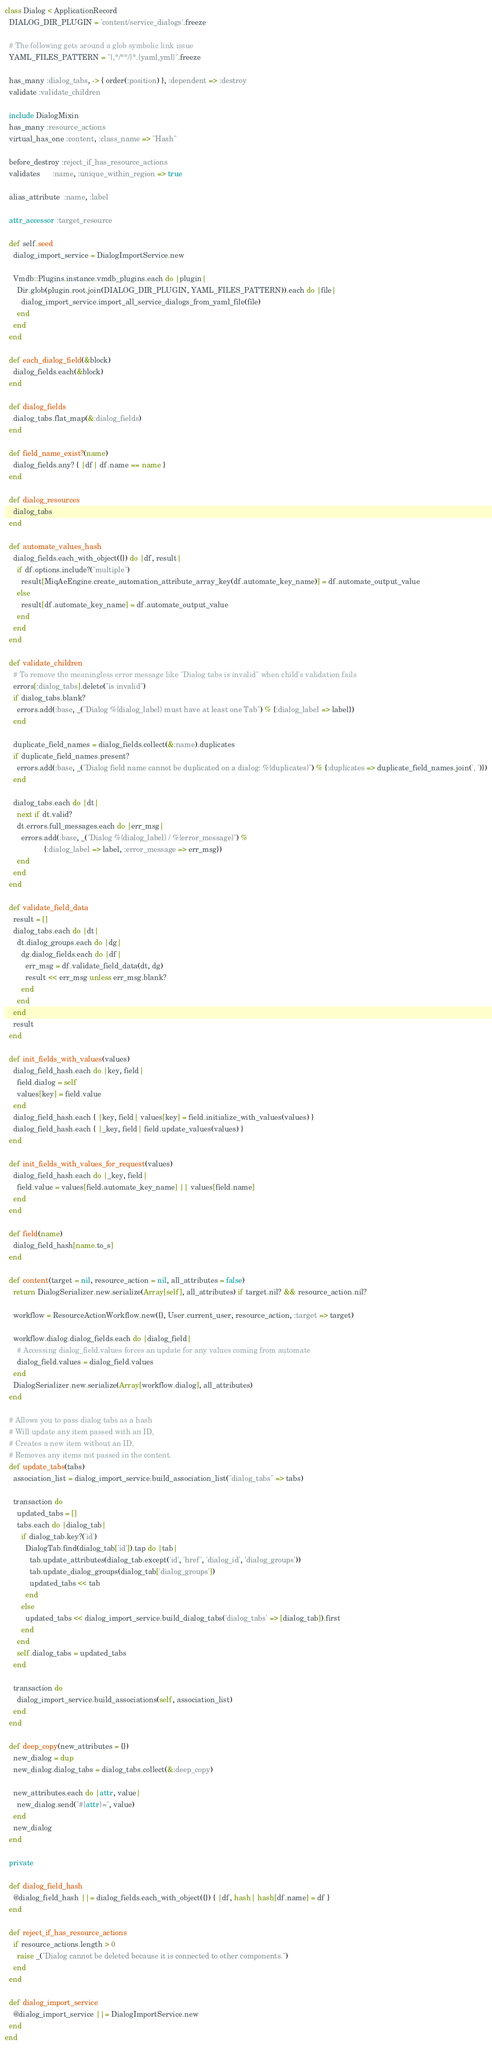<code> <loc_0><loc_0><loc_500><loc_500><_Ruby_>class Dialog < ApplicationRecord
  DIALOG_DIR_PLUGIN = 'content/service_dialogs'.freeze

  # The following gets around a glob symbolic link issue
  YAML_FILES_PATTERN = "{,*/**/}*.{yaml,yml}".freeze

  has_many :dialog_tabs, -> { order(:position) }, :dependent => :destroy
  validate :validate_children

  include DialogMixin
  has_many :resource_actions
  virtual_has_one :content, :class_name => "Hash"

  before_destroy :reject_if_has_resource_actions
  validates      :name, :unique_within_region => true

  alias_attribute  :name, :label

  attr_accessor :target_resource

  def self.seed
    dialog_import_service = DialogImportService.new

    Vmdb::Plugins.instance.vmdb_plugins.each do |plugin|
      Dir.glob(plugin.root.join(DIALOG_DIR_PLUGIN, YAML_FILES_PATTERN)).each do |file|
        dialog_import_service.import_all_service_dialogs_from_yaml_file(file)
      end
    end
  end

  def each_dialog_field(&block)
    dialog_fields.each(&block)
  end

  def dialog_fields
    dialog_tabs.flat_map(&:dialog_fields)
  end

  def field_name_exist?(name)
    dialog_fields.any? { |df| df.name == name }
  end

  def dialog_resources
    dialog_tabs
  end

  def automate_values_hash
    dialog_fields.each_with_object({}) do |df, result|
      if df.options.include?("multiple")
        result[MiqAeEngine.create_automation_attribute_array_key(df.automate_key_name)] = df.automate_output_value
      else
        result[df.automate_key_name] = df.automate_output_value
      end
    end
  end

  def validate_children
    # To remove the meaningless error message like "Dialog tabs is invalid" when child's validation fails
    errors[:dialog_tabs].delete("is invalid")
    if dialog_tabs.blank?
      errors.add(:base, _("Dialog %{dialog_label} must have at least one Tab") % {:dialog_label => label})
    end

    duplicate_field_names = dialog_fields.collect(&:name).duplicates
    if duplicate_field_names.present?
      errors.add(:base, _("Dialog field name cannot be duplicated on a dialog: %{duplicates}") % {:duplicates => duplicate_field_names.join(', ')})
    end

    dialog_tabs.each do |dt|
      next if dt.valid?
      dt.errors.full_messages.each do |err_msg|
        errors.add(:base, _("Dialog %{dialog_label} / %{error_message}") %
                   {:dialog_label => label, :error_message => err_msg})
      end
    end
  end

  def validate_field_data
    result = []
    dialog_tabs.each do |dt|
      dt.dialog_groups.each do |dg|
        dg.dialog_fields.each do |df|
          err_msg = df.validate_field_data(dt, dg)
          result << err_msg unless err_msg.blank?
        end
      end
    end
    result
  end

  def init_fields_with_values(values)
    dialog_field_hash.each do |key, field|
      field.dialog = self
      values[key] = field.value
    end
    dialog_field_hash.each { |key, field| values[key] = field.initialize_with_values(values) }
    dialog_field_hash.each { |_key, field| field.update_values(values) }
  end

  def init_fields_with_values_for_request(values)
    dialog_field_hash.each do |_key, field|
      field.value = values[field.automate_key_name] || values[field.name]
    end
  end

  def field(name)
    dialog_field_hash[name.to_s]
  end

  def content(target = nil, resource_action = nil, all_attributes = false)
    return DialogSerializer.new.serialize(Array[self], all_attributes) if target.nil? && resource_action.nil?

    workflow = ResourceActionWorkflow.new({}, User.current_user, resource_action, :target => target)

    workflow.dialog.dialog_fields.each do |dialog_field|
      # Accessing dialog_field.values forces an update for any values coming from automate
      dialog_field.values = dialog_field.values
    end
    DialogSerializer.new.serialize(Array[workflow.dialog], all_attributes)
  end

  # Allows you to pass dialog tabs as a hash
  # Will update any item passed with an ID,
  # Creates a new item without an ID,
  # Removes any items not passed in the content.
  def update_tabs(tabs)
    association_list = dialog_import_service.build_association_list("dialog_tabs" => tabs)

    transaction do
      updated_tabs = []
      tabs.each do |dialog_tab|
        if dialog_tab.key?('id')
          DialogTab.find(dialog_tab['id']).tap do |tab|
            tab.update_attributes(dialog_tab.except('id', 'href', 'dialog_id', 'dialog_groups'))
            tab.update_dialog_groups(dialog_tab['dialog_groups'])
            updated_tabs << tab
          end
        else
          updated_tabs << dialog_import_service.build_dialog_tabs('dialog_tabs' => [dialog_tab]).first
        end
      end
      self.dialog_tabs = updated_tabs
    end

    transaction do
      dialog_import_service.build_associations(self, association_list)
    end
  end

  def deep_copy(new_attributes = {})
    new_dialog = dup
    new_dialog.dialog_tabs = dialog_tabs.collect(&:deep_copy)

    new_attributes.each do |attr, value|
      new_dialog.send("#{attr}=", value)
    end
    new_dialog
  end

  private

  def dialog_field_hash
    @dialog_field_hash ||= dialog_fields.each_with_object({}) { |df, hash| hash[df.name] = df }
  end

  def reject_if_has_resource_actions
    if resource_actions.length > 0
      raise _("Dialog cannot be deleted because it is connected to other components.")
    end
  end

  def dialog_import_service
    @dialog_import_service ||= DialogImportService.new
  end
end
</code> 